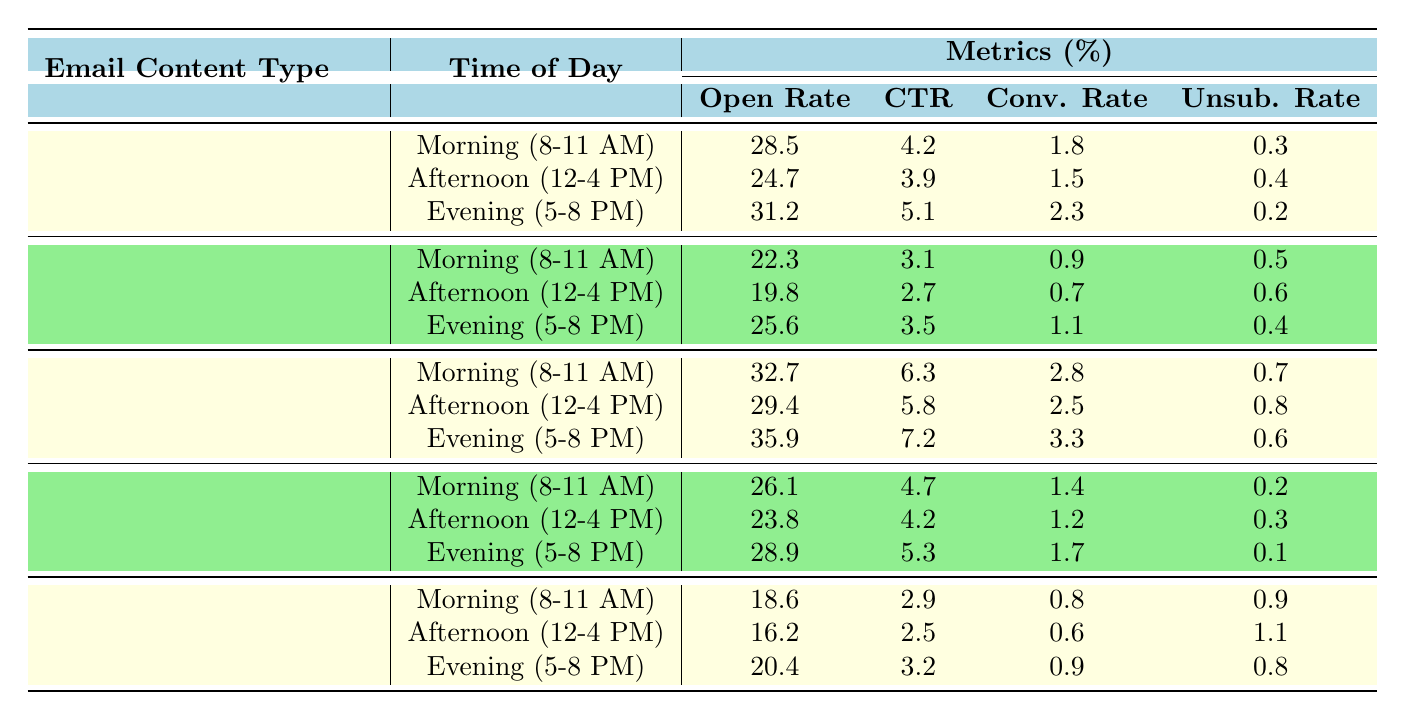What is the Open Rate for Promotional Offer in the Evening? The row for Promotional Offer under the Evening time indicates an Open Rate of 35.9%.
Answer: 35.9 Which time of day has the lowest Click Through Rate for the Newsletter content type? The Click Through Rate for the Newsletter is lowest in the Afternoon (12-4 PM) at 2.7%.
Answer: 2.7 What is the average Conversion Rate for Product Launch emails? The Conversion Rates for Product Launch are 1.8%, 1.5%, and 2.3%. Adding them gives 1.8 + 1.5 + 2.3 = 5.6%, and dividing by 3 gives an average of 5.6 / 3 = 1.87%.
Answer: 1.87 Did the Event Invitation emails have a higher Open Rate in the Morning or Evening? The Open Rate for Event Invitations in the Morning is 26.1%, while in the Evening it is 28.9%. Since 28.9% is greater than 26.1%, the Evening showed a higher Open Rate.
Answer: Yes Which content type has the highest Unsubscribe Rate in the Afternoon? In the Afternoon, the Unsubscribe Rate for Customer Feedback Survey is 1.1%, which is the highest when compared to the other content types.
Answer: Customer Feedback Survey What is the difference between the highest and lowest Open Rates for all content types in the Evening? The highest Open Rate in the Evening is 35.9% (Promotional Offer), and the lowest is 20.4% (Customer Feedback Survey). The difference is 35.9 - 20.4 = 15.5%.
Answer: 15.5 Is the Click Through Rate for Event Invitations lower in the Afternoon compared to the Morning? The Click Through Rate for Event Invitations is 4.2% in the Afternoon and 4.7% in the Morning. Since 4.2% is lower than 4.7%, the statement is true.
Answer: Yes What is the combined Open Rate for all content types in the Morning? The Open Rates for each content type in the Morning are: Product Launch (28.5), Newsletter (22.3), Promotional Offer (32.7), Event Invitation (26.1), and Customer Feedback Survey (18.6). Combining these gives 28.5 + 22.3 + 32.7 + 26.1 + 18.6 = 128.2%.
Answer: 128.2 How does the Unsubscribe Rate for Promotional Offer in the Morning compare to that of Customer Feedback Survey in the Evening? The Unsubscribe Rate for Promotional Offer in the Morning is 0.7% and for Customer Feedback Survey in the Evening is 0.8%. Since 0.7% is less than 0.8%, it is lower.
Answer: Promotional Offer is lower 